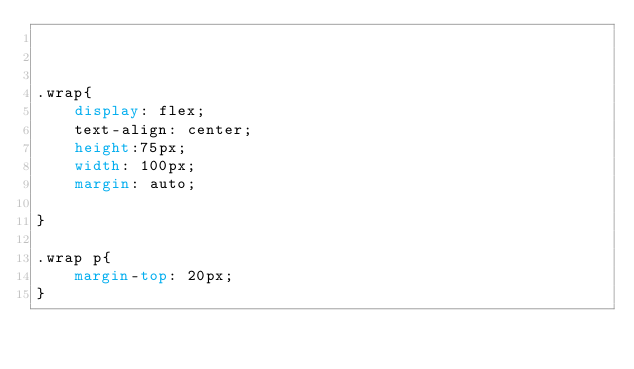<code> <loc_0><loc_0><loc_500><loc_500><_CSS_>


.wrap{
    display: flex;
    text-align: center;
    height:75px;
    width: 100px;
    margin: auto;
    
}

.wrap p{
    margin-top: 20px;
}



</code> 